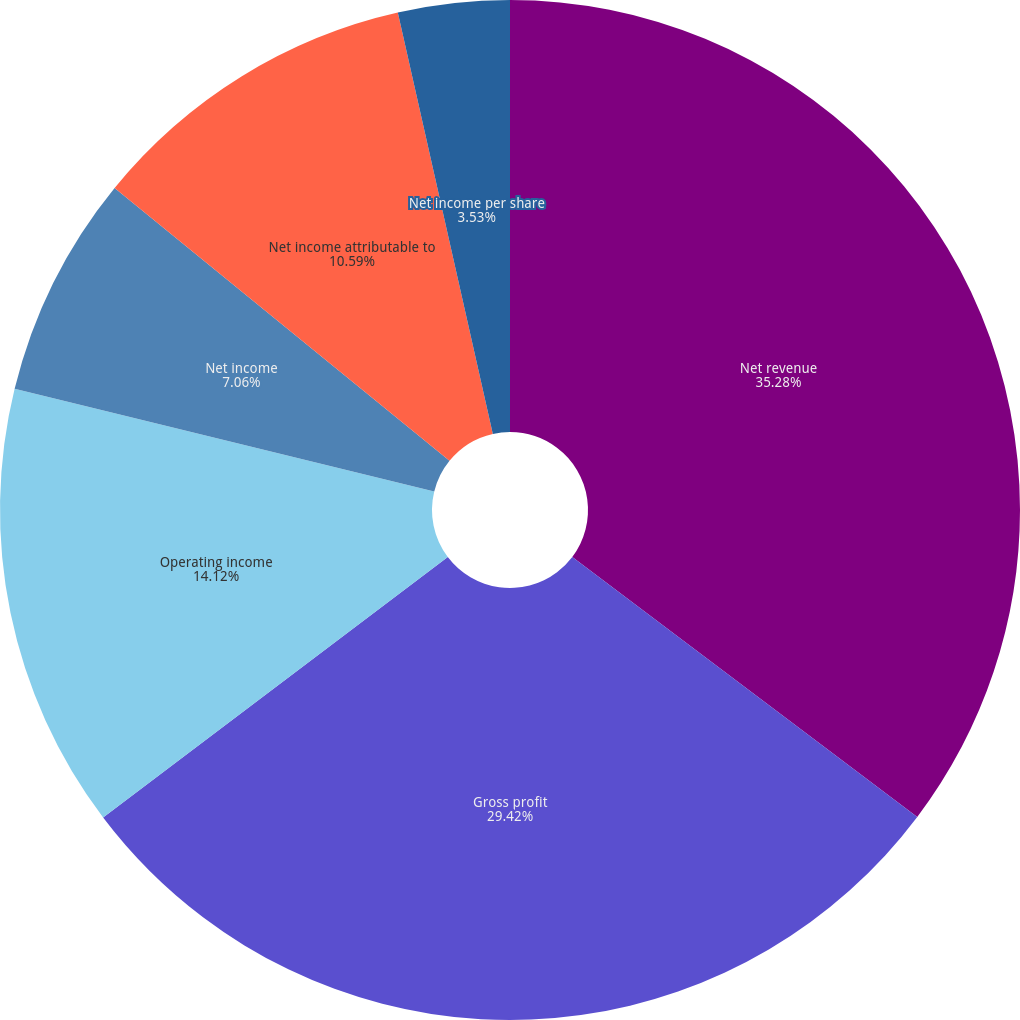Convert chart. <chart><loc_0><loc_0><loc_500><loc_500><pie_chart><fcel>Net revenue<fcel>Gross profit<fcel>Operating income<fcel>Net income<fcel>Net income attributable to<fcel>Net income per share<nl><fcel>35.28%<fcel>29.42%<fcel>14.12%<fcel>7.06%<fcel>10.59%<fcel>3.53%<nl></chart> 